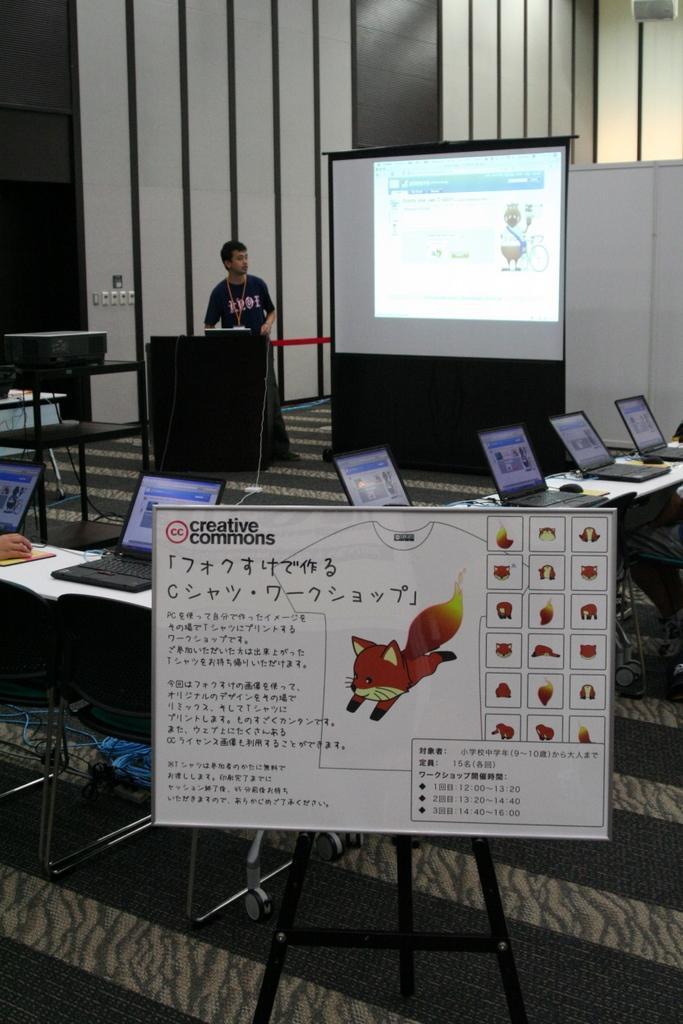How would you summarize this image in a sentence or two? In this image I can see a board. To the back of the board there are many laptops on the table. In the background there is a person standing in front of the screen. 